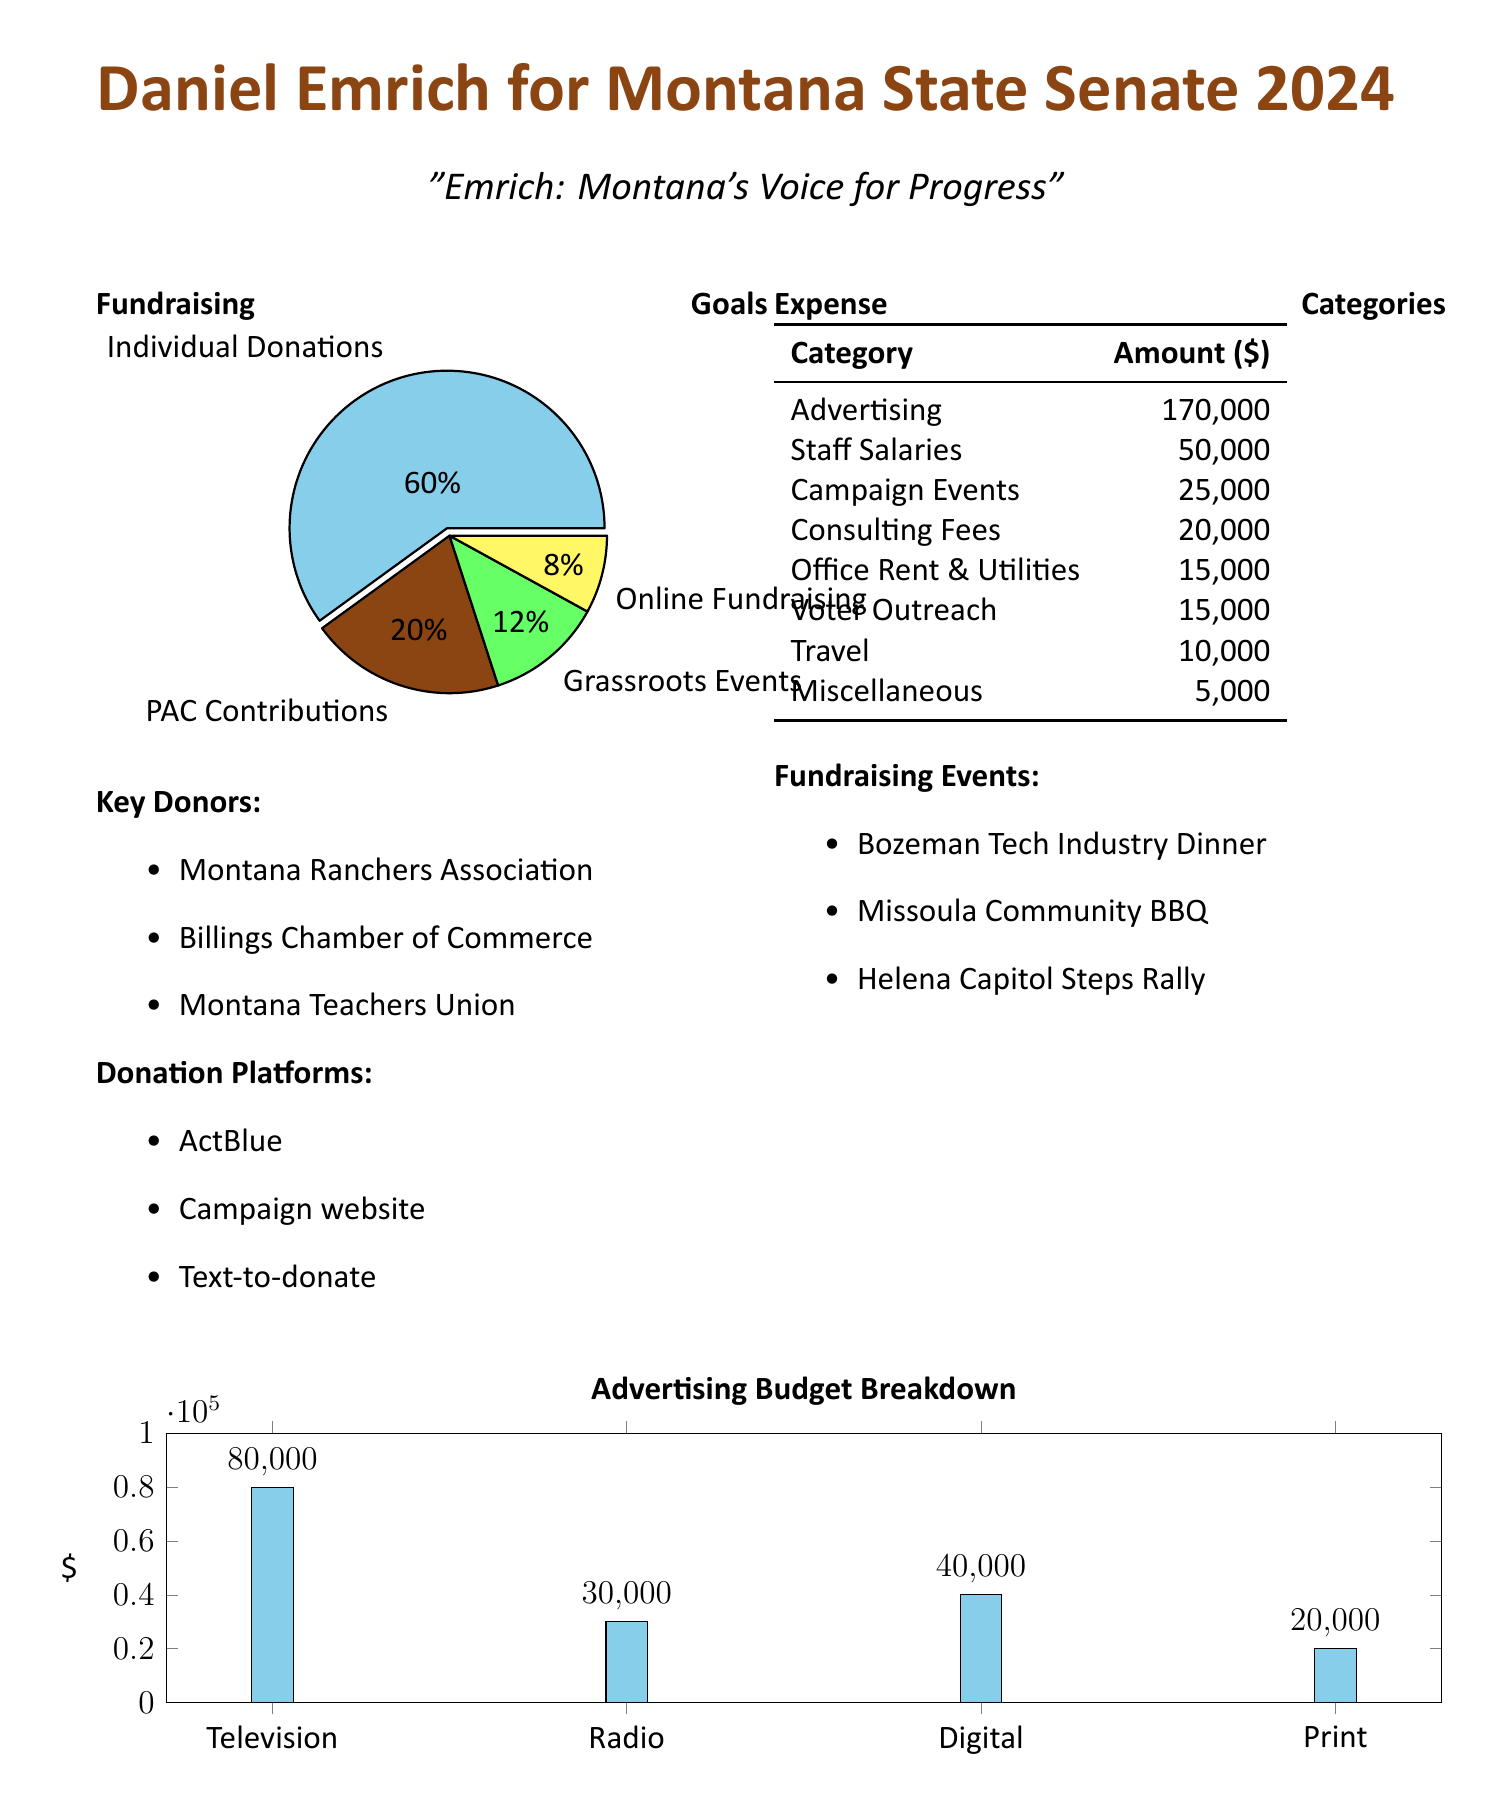What is the fundraising goal for individual donations? The fundraising goal for individual donations is the largest portion at 60% of the total goal, as shown in the pie chart.
Answer: 60% What is the amount allocated for staff salaries? The document lists staff salaries as one of the expense categories with a specific amount allocated for it.
Answer: 50,000 Which organization is listed as a key donor? A list of key donors is provided, and one of the organizations mentioned is a key donor.
Answer: Montana Ranchers Association What is the total amount dedicated to advertising? The document contains a specific category dedicated to advertising with a defined monetary amount.
Answer: 170,000 What percentage of the budget is for PAC contributions? The pie chart illustrates the fundraising goals and shows the percentage allocated for PAC contributions.
Answer: 20% How much is allocated for travel expenses? Travel expenses are listed as one of the expense categories in the budget.
Answer: 10,000 What fundraising event is scheduled in Bozeman? The document lists specific fundraising events, and one takes place in Bozeman.
Answer: Bozeman Tech Industry Dinner What is the amount budgeted for voter outreach? The budget outlines specific amounts for different expense categories, including voter outreach.
Answer: 15,000 What is the total budget for digital advertising? The bar chart breaks down the advertising budget into categories, including the digital segment.
Answer: 40,000 